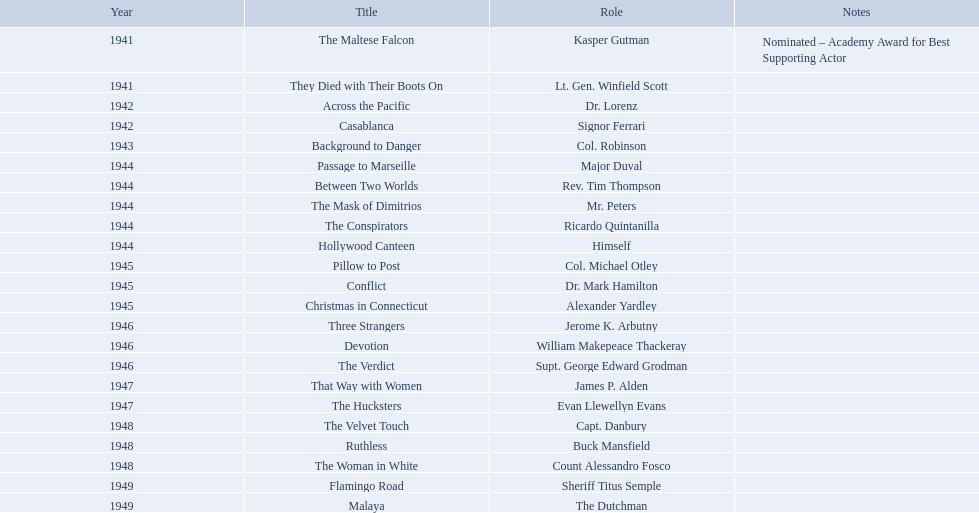What year was the movie that was nominated ? 1941. What was the title of the movie? The Maltese Falcon. What are the movies? The Maltese Falcon, They Died with Their Boots On, Across the Pacific, Casablanca, Background to Danger, Passage to Marseille, Between Two Worlds, The Mask of Dimitrios, The Conspirators, Hollywood Canteen, Pillow to Post, Conflict, Christmas in Connecticut, Three Strangers, Devotion, The Verdict, That Way with Women, The Hucksters, The Velvet Touch, Ruthless, The Woman in White, Flamingo Road, Malaya. Of these, for which did he get nominated for an oscar? The Maltese Falcon. In what films did sydney greenstreet act? The Maltese Falcon, They Died with Their Boots On, Across the Pacific, Casablanca, Background to Danger, Passage to Marseille, Between Two Worlds, The Mask of Dimitrios, The Conspirators, Hollywood Canteen, Pillow to Post, Conflict, Christmas in Connecticut, Three Strangers, Devotion, The Verdict, That Way with Women, The Hucksters, The Velvet Touch, Ruthless, The Woman in White, Flamingo Road, Malaya. What are all the title comments? Nominated – Academy Award for Best Supporting Actor. Which movie won the award? The Maltese Falcon. In which year was the nominated movie released? 1941. What is the name of that film? The Maltese Falcon. 